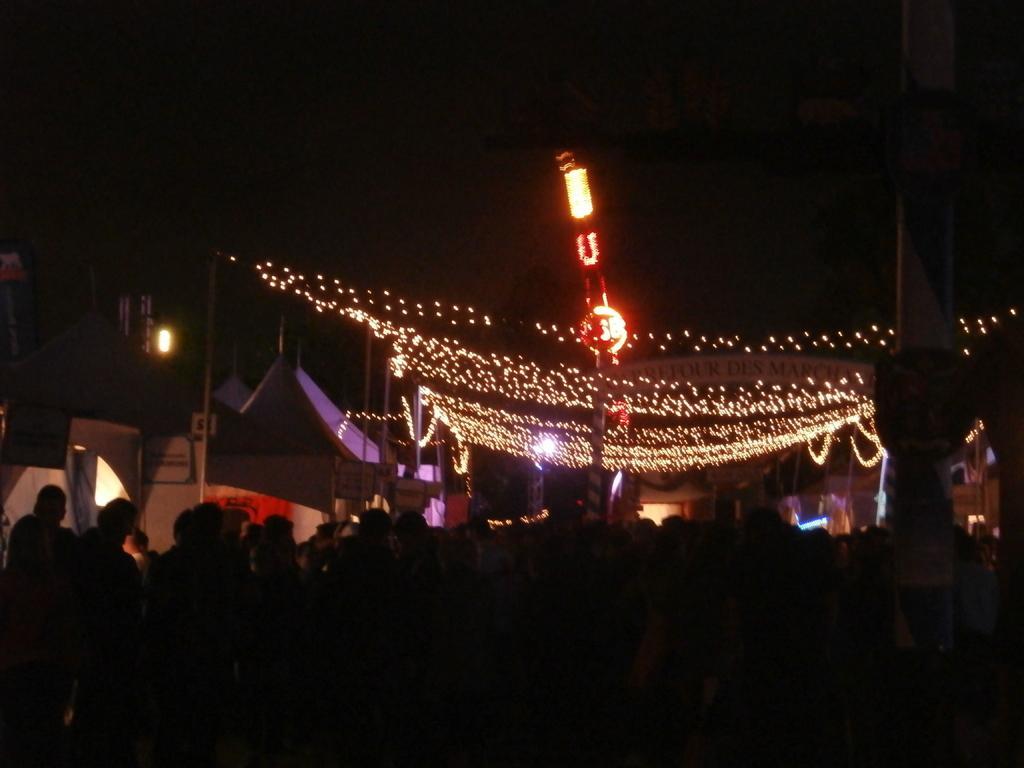Describe this image in one or two sentences. The image is dark but at the bottom we can see few persons and in the background we can see decorative lights, poles and other objects. 